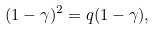Convert formula to latex. <formula><loc_0><loc_0><loc_500><loc_500>( 1 - \gamma ) ^ { 2 } = q ( 1 - \gamma ) ,</formula> 